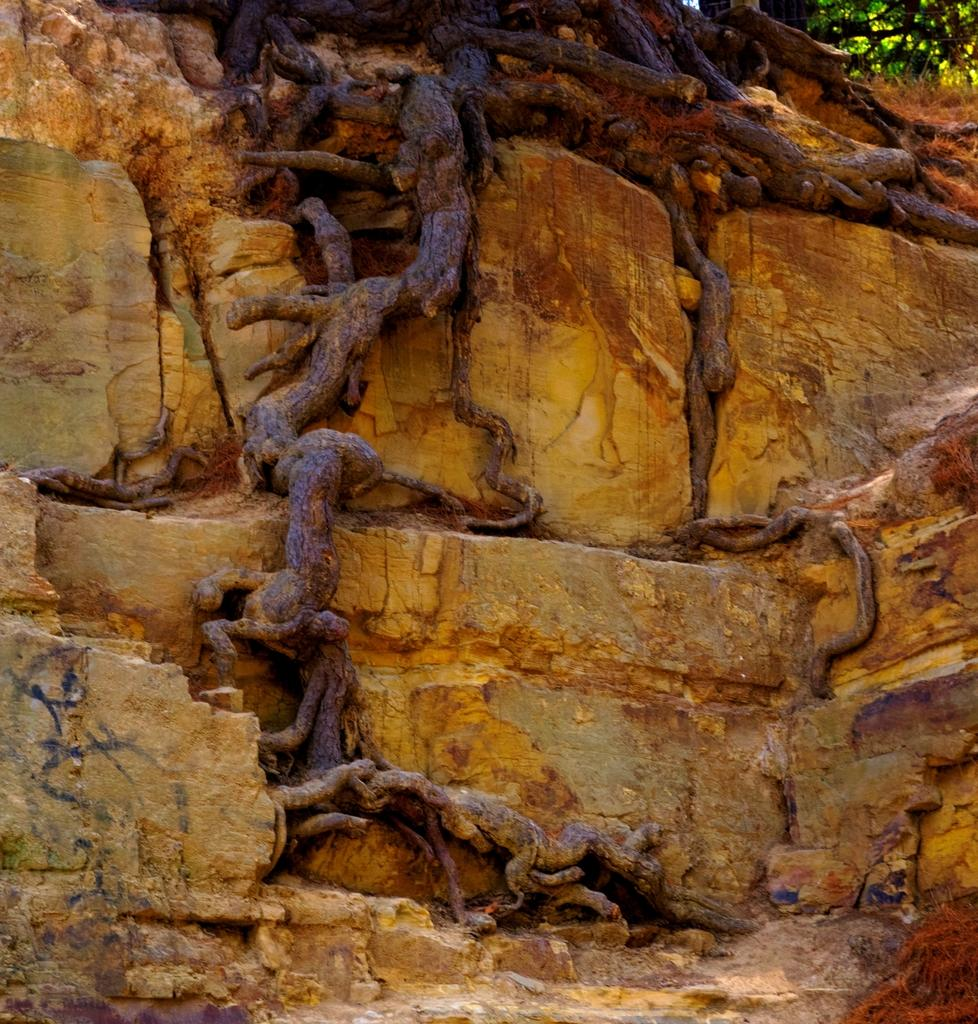What type of natural elements can be seen in the image? There are roots, plants, and rocks visible in the image. Can you describe the plants in the image? The image contains plants, but no specific details about their type or appearance are provided. What other natural elements might be present in the image? Based on the provided facts, we can only confirm the presence of roots, plants, and rocks. How does the crow interact with the plants in the image? There is no crow present in the image, so it cannot interact with the plants. What type of animal can be seen in the image? There is no animal present in the image, only roots, plants, and rocks. 